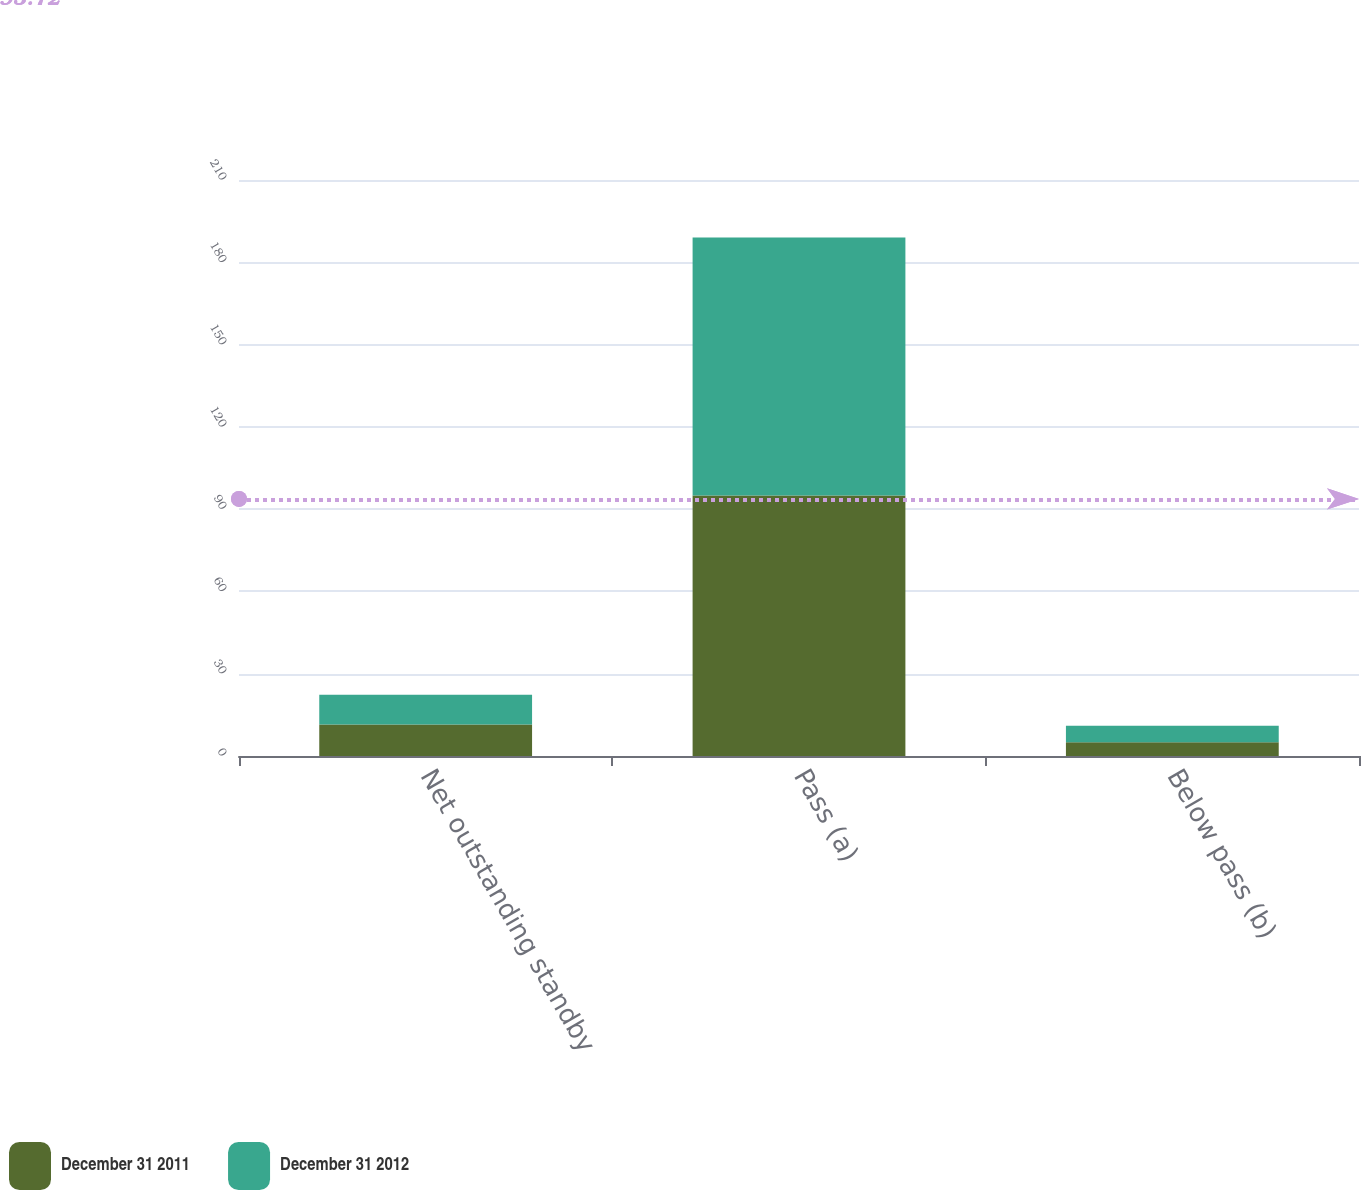<chart> <loc_0><loc_0><loc_500><loc_500><stacked_bar_chart><ecel><fcel>Net outstanding standby<fcel>Pass (a)<fcel>Below pass (b)<nl><fcel>December 31 2011<fcel>11.5<fcel>95<fcel>5<nl><fcel>December 31 2012<fcel>10.8<fcel>94<fcel>6<nl></chart> 